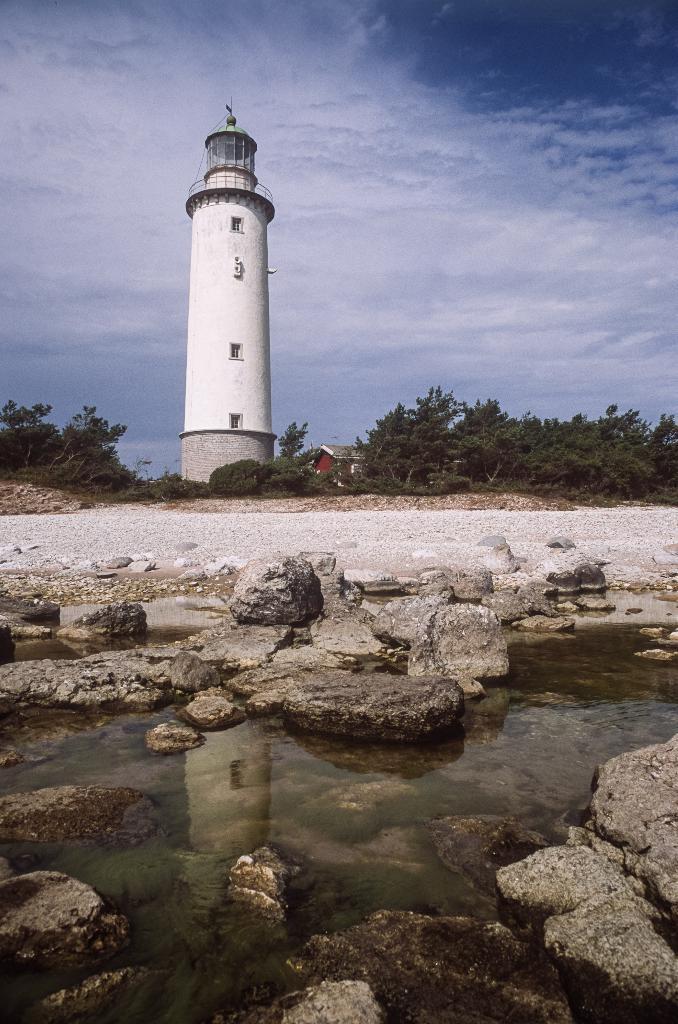How would you summarize this image in a sentence or two? In the picture we can see a rock surface on it, we can see some rocks and water and in the background, we can see some plants, trees and a lighthouse which is white in color and behind it we can see a sky with clouds. 